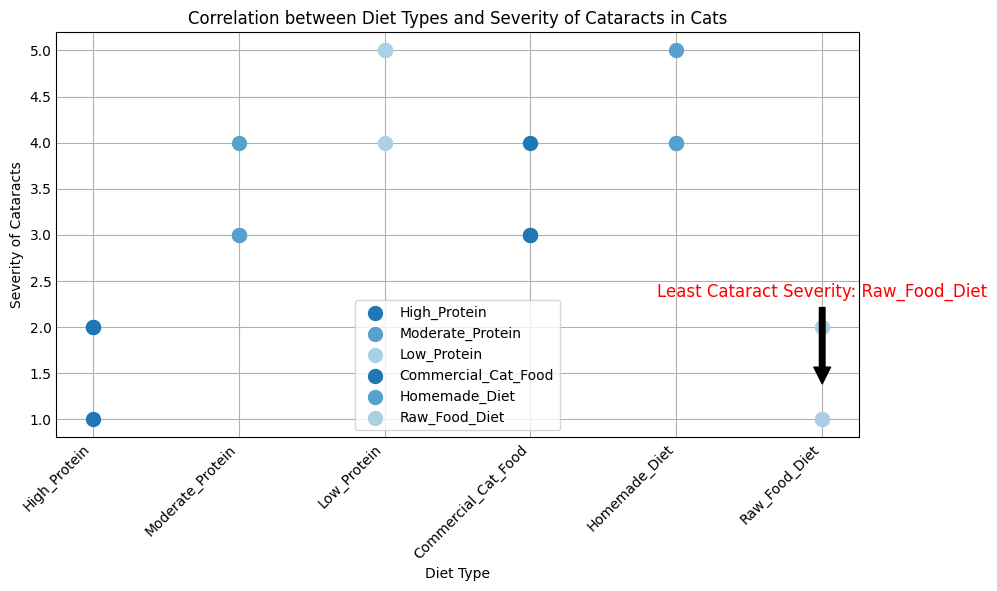What diet type has the least average severity of cataracts? Based on the annotation in the plot, the least cataract severity is associated with a specific diet type. The text indicates that this diet type is Raw Food Diet.
Answer: Raw Food Diet Which diet type has the highest observed severity of cataracts? By examining the scatter plot visually, the points representing Low Protein and Homemade Diets have the highest values at 5.
Answer: Low Protein, Homemade Diet What is the difference in average severity between High Protein diet and Raw Food Diet? First, calculate the average severity for each diet type from the data. High Protein has averages of (2+1+2)/3 = 1.67, and Raw Food Diet has (2+1+1)/3 = 1.33. The difference is 1.67 - 1.33 = 0.34.
Answer: 0.34 How many diet types have an average severity of more than 3? Average the severity for each diet type and count those above 3. High Protein (1.67), Moderate Protein (3.33), Low Protein (4.67), Commercial Cat Food (3.33), Homemade Diet (4.33), Raw Food Diet (1.33). The diets with averages over 3 are Moderate Protein, Low Protein, Commercial Cat Food, and Homemade Diet.
Answer: 4 Which diet type shows the widest range of severity values? Determine the range for each diet type from the scatter plot. High Protein range=1; Moderate Protein range=1; Low Protein range=1; Commercial Cat Food range=1; Homemade Diet range=1; Raw Food Diet range=1. All diet types show a range of 1, thus they have the same range of severity values.
Answer: All diet types (same range) How does the severity of cataracts in Commercial Cat Food compare to that of Homemade Diet? Visually compare the scatter plot points. Both Commercial Cat Food and Homemade Diet show severity values of 3 and 4, with Homemade Diet extending to 5 more frequently.
Answer: Similar What is the maximum observed severity value and which diets show this value? Identify the highest points on the scatter plot. The maximum observed value is 5, seen in Low Protein and Homemade Diet.
Answer: 5, Low Protein, Homemade Diet What is the minimum severity observed for cats on a Raw Food Diet? Look at the scatter points for Raw Food Diet to find the lowest value.
Answer: 1 Which diet type appears to have the most variability in the severity of cataracts? By examining the scatter plot, though all have a numerical range of 1, Low Protein and Homemade Diet scatter around higher values, indicating more frequent severe cases, suggesting higher perception of variability.
Answer: Low Protein, Homemade Diet 